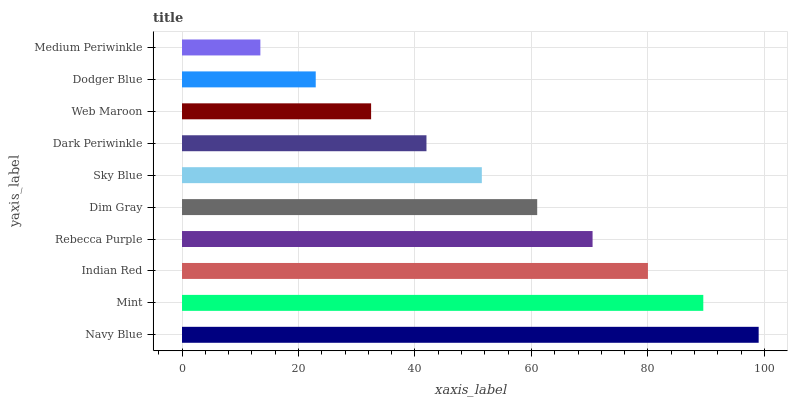Is Medium Periwinkle the minimum?
Answer yes or no. Yes. Is Navy Blue the maximum?
Answer yes or no. Yes. Is Mint the minimum?
Answer yes or no. No. Is Mint the maximum?
Answer yes or no. No. Is Navy Blue greater than Mint?
Answer yes or no. Yes. Is Mint less than Navy Blue?
Answer yes or no. Yes. Is Mint greater than Navy Blue?
Answer yes or no. No. Is Navy Blue less than Mint?
Answer yes or no. No. Is Dim Gray the high median?
Answer yes or no. Yes. Is Sky Blue the low median?
Answer yes or no. Yes. Is Rebecca Purple the high median?
Answer yes or no. No. Is Rebecca Purple the low median?
Answer yes or no. No. 